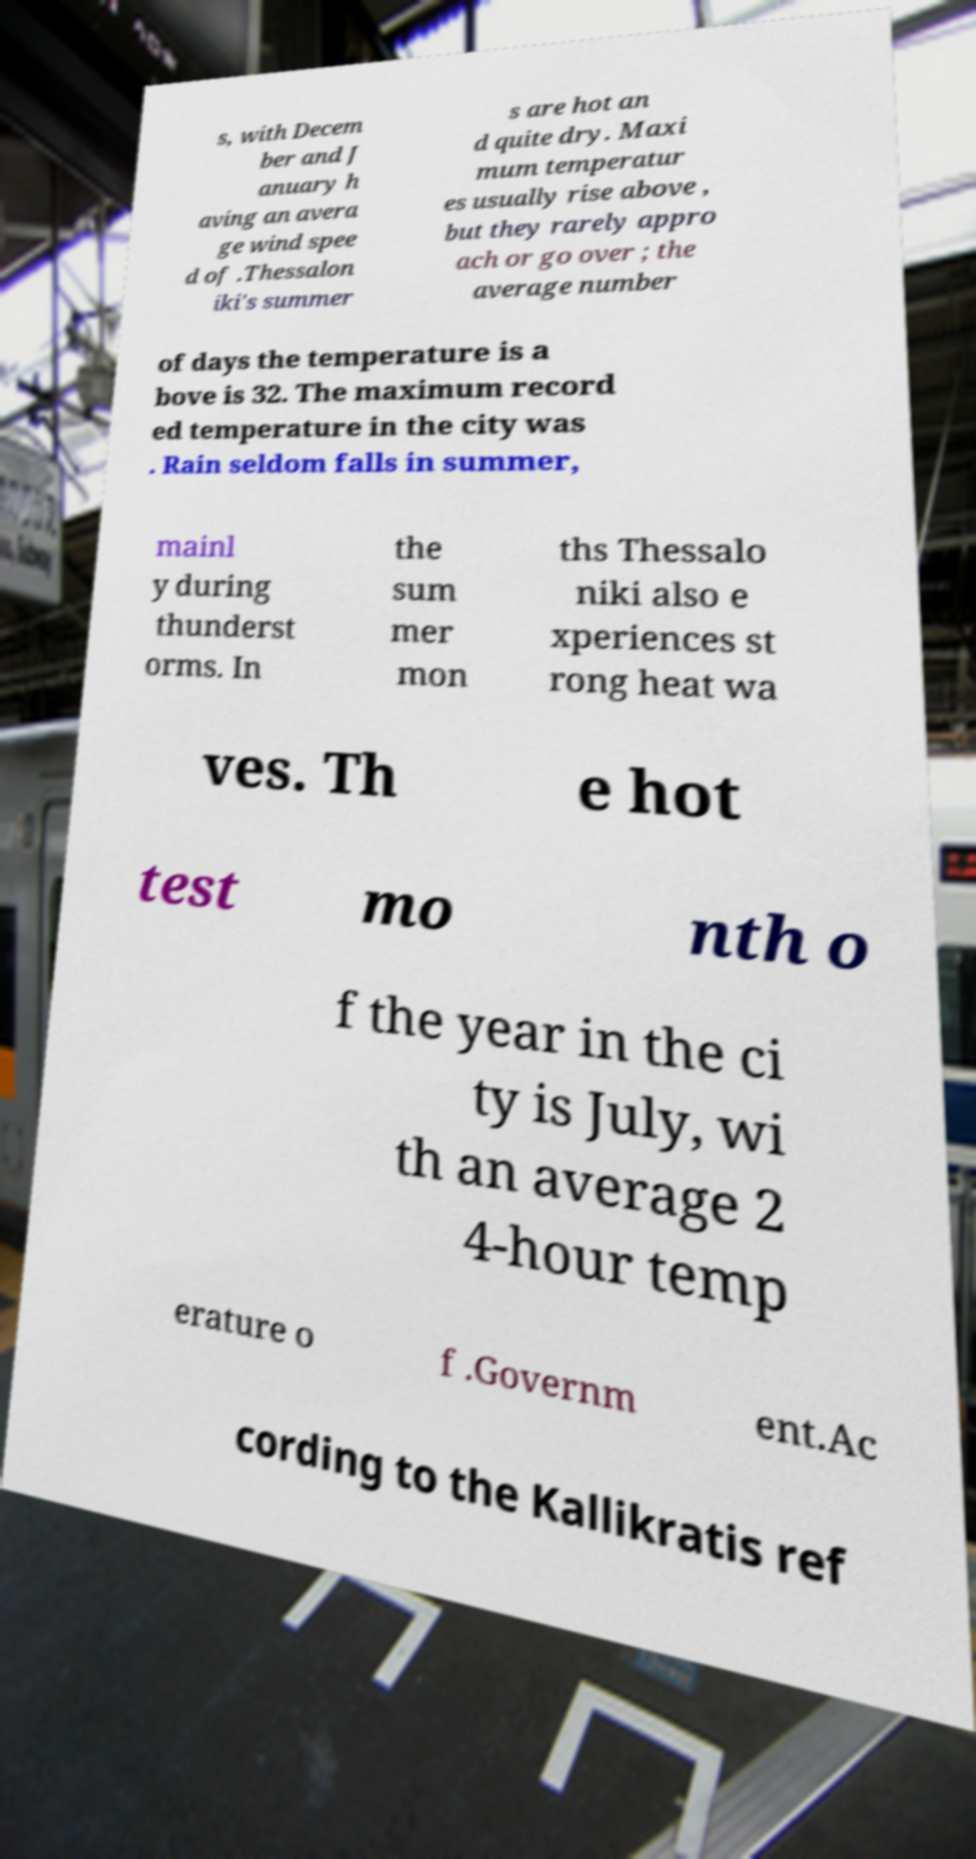Can you accurately transcribe the text from the provided image for me? s, with Decem ber and J anuary h aving an avera ge wind spee d of .Thessalon iki's summer s are hot an d quite dry. Maxi mum temperatur es usually rise above , but they rarely appro ach or go over ; the average number of days the temperature is a bove is 32. The maximum record ed temperature in the city was . Rain seldom falls in summer, mainl y during thunderst orms. In the sum mer mon ths Thessalo niki also e xperiences st rong heat wa ves. Th e hot test mo nth o f the year in the ci ty is July, wi th an average 2 4-hour temp erature o f .Governm ent.Ac cording to the Kallikratis ref 